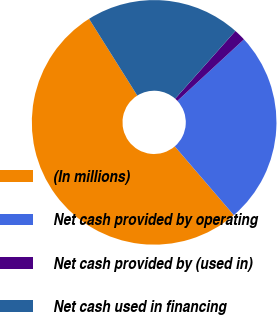Convert chart. <chart><loc_0><loc_0><loc_500><loc_500><pie_chart><fcel>(In millions)<fcel>Net cash provided by operating<fcel>Net cash provided by (used in)<fcel>Net cash used in financing<nl><fcel>52.37%<fcel>25.58%<fcel>1.56%<fcel>20.5%<nl></chart> 